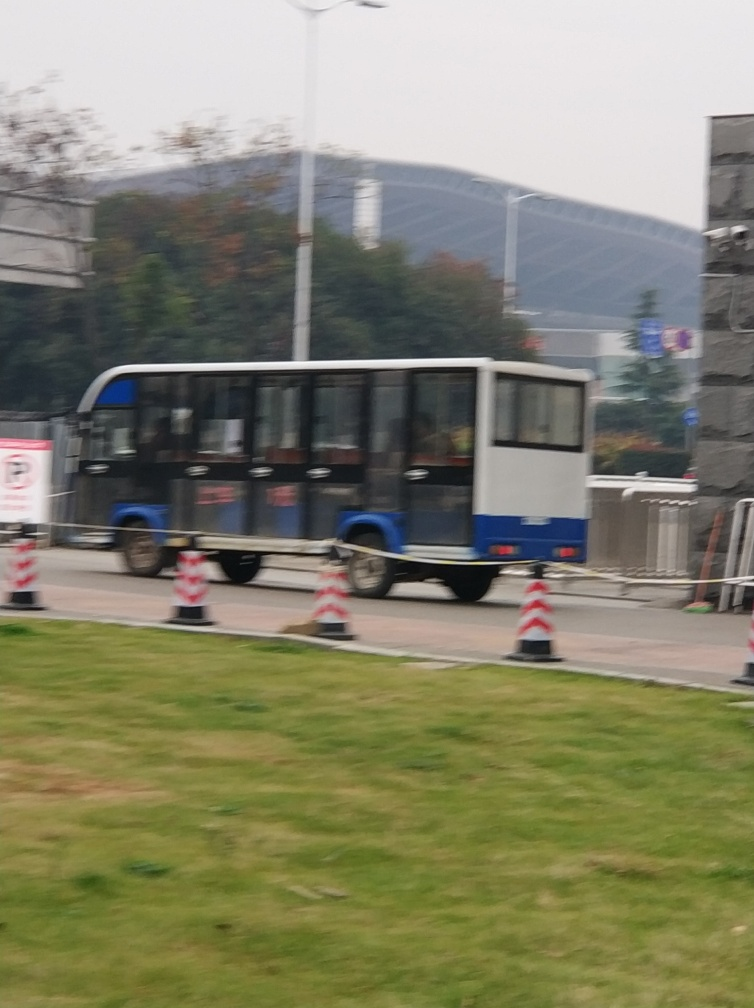Can you tell what time of the day it might be? While the exact time is unclear due to the overcast sky, the level of natural light suggests it could be either late morning or early afternoon. 